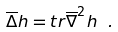<formula> <loc_0><loc_0><loc_500><loc_500>\overline { \Delta } h = t r \overline { \nabla } ^ { 2 } h \ .</formula> 